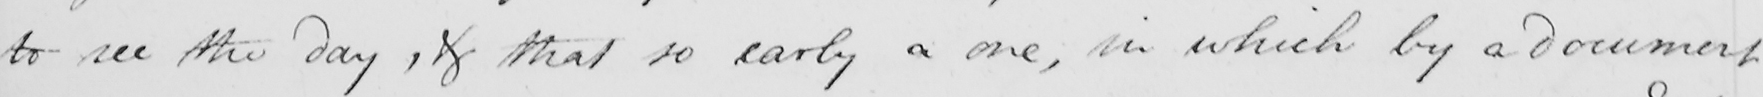What text is written in this handwritten line? to see the day , & that so early a one , in which by a document 